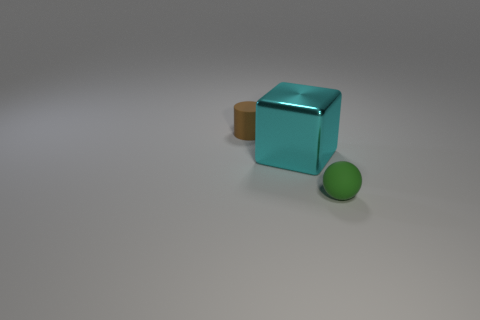What number of balls are large blue objects or cyan objects?
Your answer should be very brief. 0. The thing that is both behind the ball and in front of the brown object has what shape?
Offer a very short reply. Cube. Are there any cyan blocks of the same size as the cyan object?
Give a very brief answer. No. How many things are either objects that are on the right side of the tiny cylinder or brown cylinders?
Your answer should be compact. 3. Is the cylinder made of the same material as the small object in front of the tiny rubber cylinder?
Provide a short and direct response. Yes. What number of other objects are there of the same shape as the large cyan object?
Make the answer very short. 0. How many objects are small things behind the tiny ball or things that are left of the matte sphere?
Give a very brief answer. 2. How many other things are the same color as the cube?
Your response must be concise. 0. Are there fewer brown cylinders right of the metal cube than tiny green objects left of the tiny ball?
Your response must be concise. No. How many blue cylinders are there?
Offer a terse response. 0. 